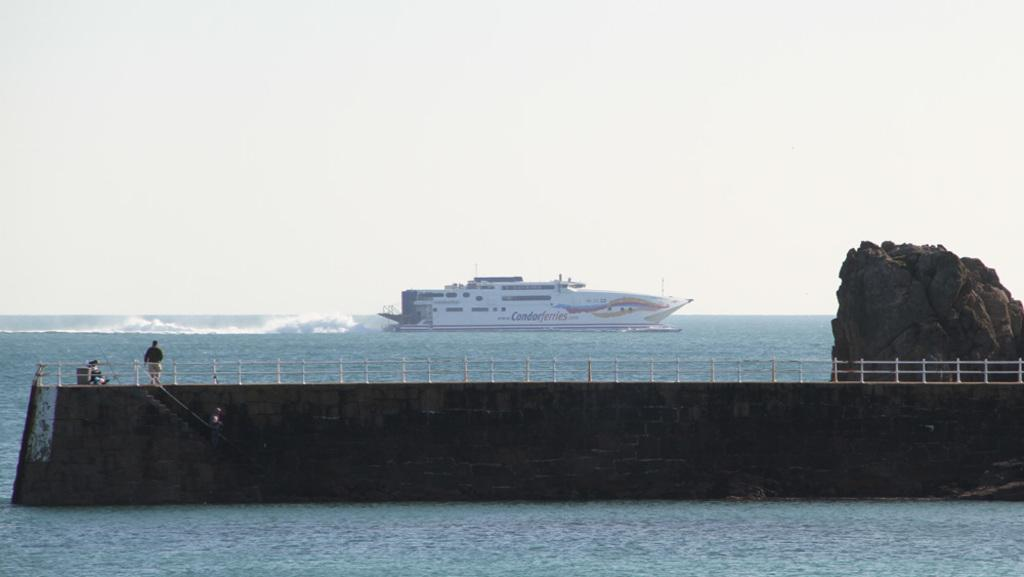What is the primary subject in the image? There is a person standing in the image. Can you describe the person's attire? The person is wearing clothes. What type of structure can be seen in the image? There is a bridge in the image. What other features are present in the image? There is a fence, water, a hill, and a ship in the water. How would you describe the sky in the image? The sky is white in the image. What type of soda is being poured into the water in the image? There is no soda present in the image; it features a person, a bridge, a fence, water, a hill, and a ship, with a white sky. 